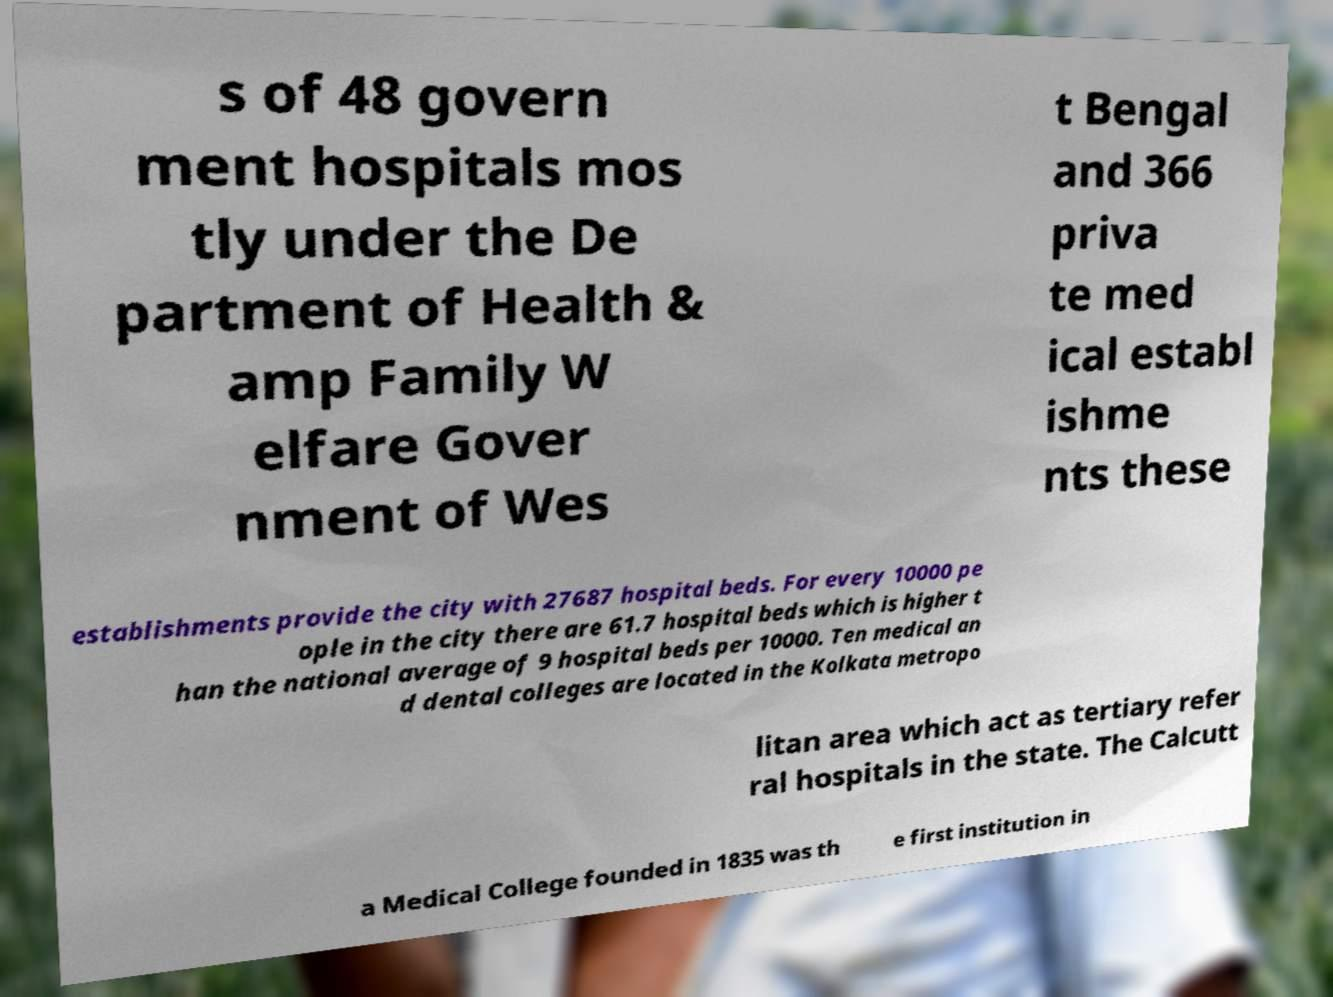There's text embedded in this image that I need extracted. Can you transcribe it verbatim? s of 48 govern ment hospitals mos tly under the De partment of Health & amp Family W elfare Gover nment of Wes t Bengal and 366 priva te med ical establ ishme nts these establishments provide the city with 27687 hospital beds. For every 10000 pe ople in the city there are 61.7 hospital beds which is higher t han the national average of 9 hospital beds per 10000. Ten medical an d dental colleges are located in the Kolkata metropo litan area which act as tertiary refer ral hospitals in the state. The Calcutt a Medical College founded in 1835 was th e first institution in 